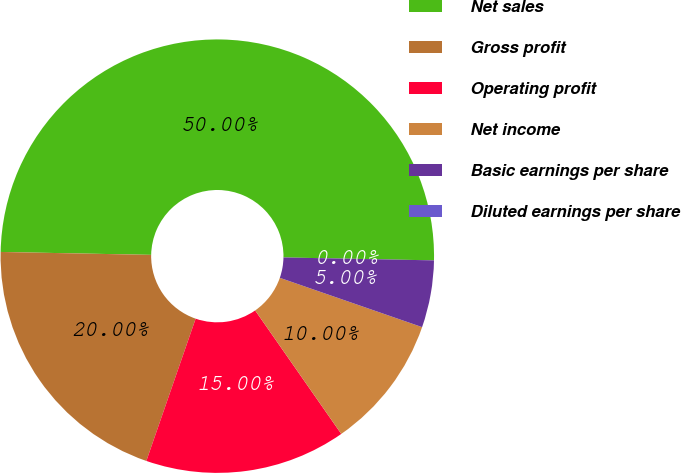Convert chart. <chart><loc_0><loc_0><loc_500><loc_500><pie_chart><fcel>Net sales<fcel>Gross profit<fcel>Operating profit<fcel>Net income<fcel>Basic earnings per share<fcel>Diluted earnings per share<nl><fcel>50.0%<fcel>20.0%<fcel>15.0%<fcel>10.0%<fcel>5.0%<fcel>0.0%<nl></chart> 